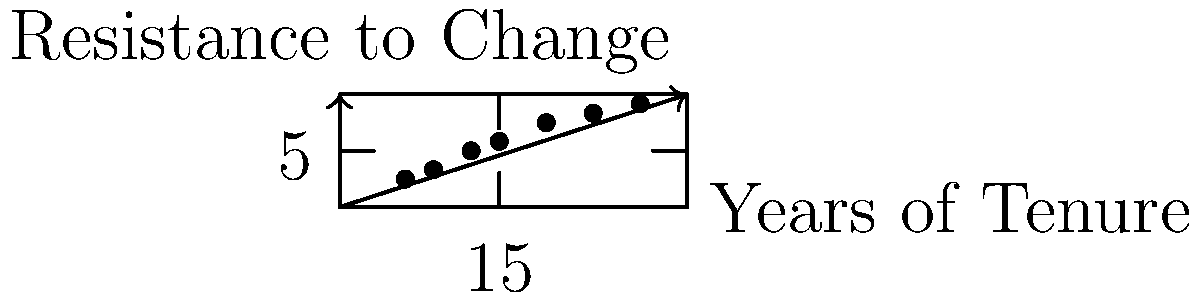Based on the scatter plot showing the relationship between years of tenure and resistance to change among academics, what can be inferred about the correlation between these two variables? To analyze the correlation between years of tenure and resistance to change:

1. Observe the overall trend: As years of tenure increase, resistance to change also increases.

2. Assess the pattern: The points form a roughly linear pattern from bottom-left to top-right.

3. Evaluate the strength: The points are close to an imaginary line, indicating a strong correlation.

4. Determine the direction: The upward trend shows a positive correlation.

5. Consider outliers: There are no significant outliers that deviate from the general trend.

6. Quantify the relationship: Without calculating, we can visually estimate a strong positive correlation, likely above 0.8 on a scale from -1 to 1.

7. Interpret the findings: Longer tenure is associated with higher resistance to change in academic settings.

Given these observations, we can conclude that there is a strong positive correlation between years of tenure and resistance to change among academics.
Answer: Strong positive correlation 